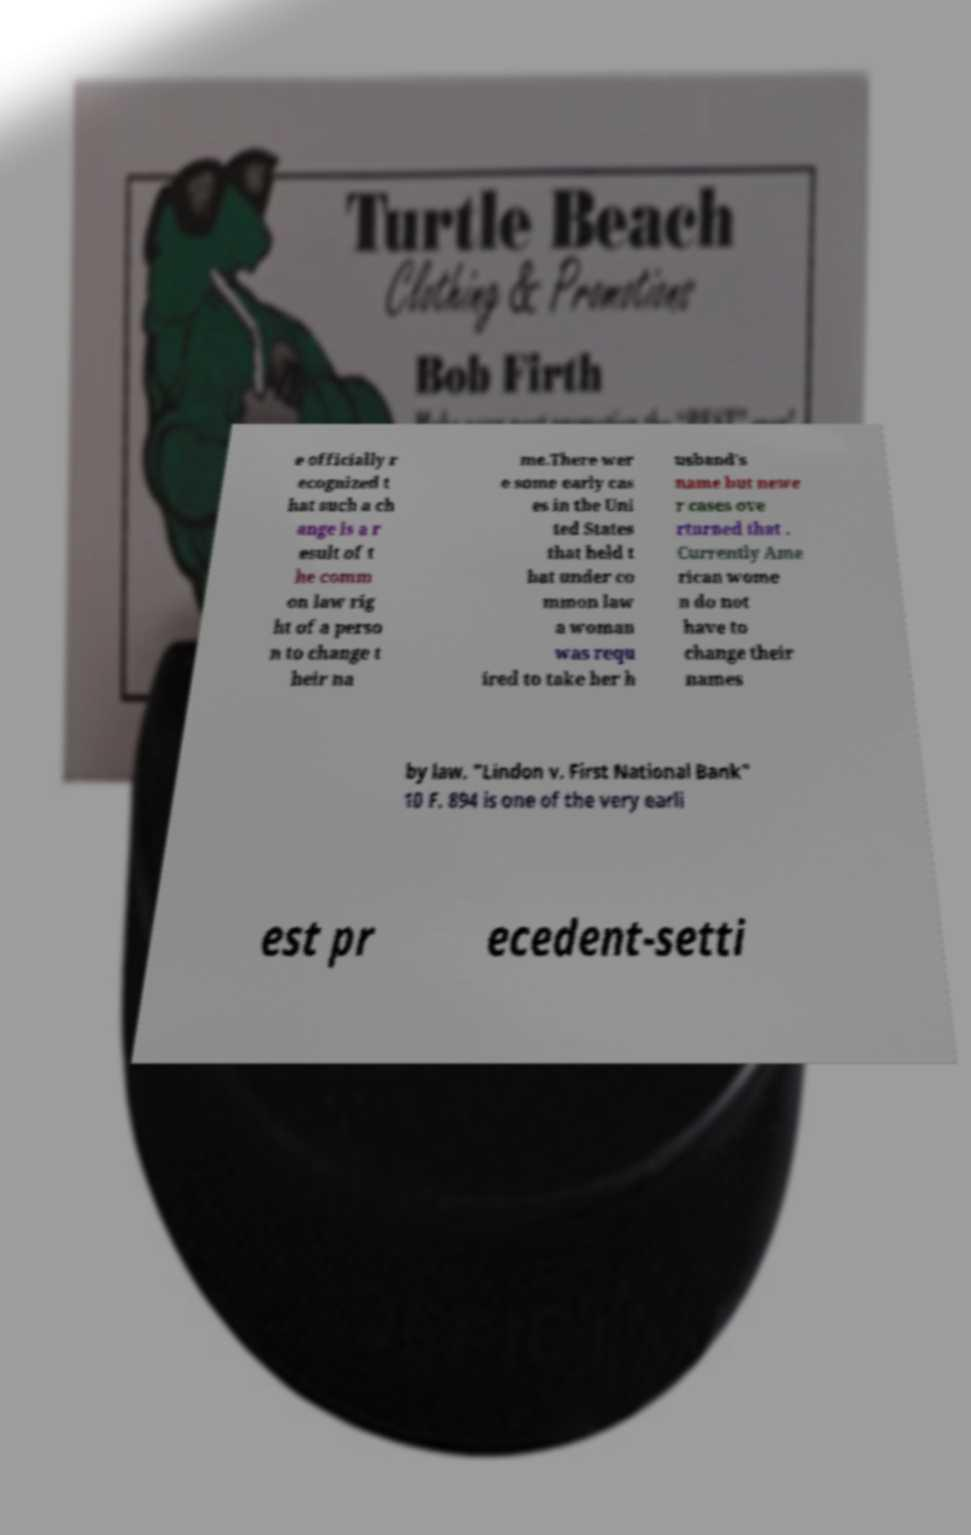Could you extract and type out the text from this image? e officially r ecognized t hat such a ch ange is a r esult of t he comm on law rig ht of a perso n to change t heir na me.There wer e some early cas es in the Uni ted States that held t hat under co mmon law a woman was requ ired to take her h usband's name but newe r cases ove rturned that . Currently Ame rican wome n do not have to change their names by law. "Lindon v. First National Bank" 10 F. 894 is one of the very earli est pr ecedent-setti 